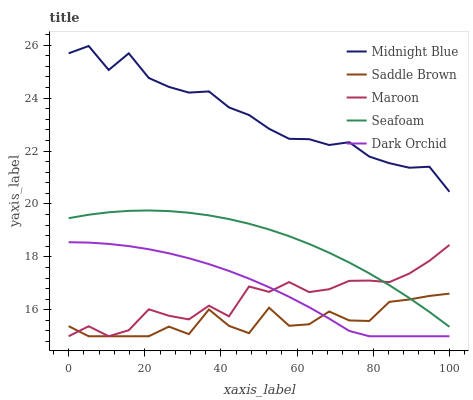Does Saddle Brown have the minimum area under the curve?
Answer yes or no. Yes. Does Midnight Blue have the maximum area under the curve?
Answer yes or no. Yes. Does Seafoam have the minimum area under the curve?
Answer yes or no. No. Does Seafoam have the maximum area under the curve?
Answer yes or no. No. Is Seafoam the smoothest?
Answer yes or no. Yes. Is Saddle Brown the roughest?
Answer yes or no. Yes. Is Midnight Blue the smoothest?
Answer yes or no. No. Is Midnight Blue the roughest?
Answer yes or no. No. Does Dark Orchid have the lowest value?
Answer yes or no. Yes. Does Seafoam have the lowest value?
Answer yes or no. No. Does Midnight Blue have the highest value?
Answer yes or no. Yes. Does Seafoam have the highest value?
Answer yes or no. No. Is Seafoam less than Midnight Blue?
Answer yes or no. Yes. Is Midnight Blue greater than Dark Orchid?
Answer yes or no. Yes. Does Seafoam intersect Maroon?
Answer yes or no. Yes. Is Seafoam less than Maroon?
Answer yes or no. No. Is Seafoam greater than Maroon?
Answer yes or no. No. Does Seafoam intersect Midnight Blue?
Answer yes or no. No. 